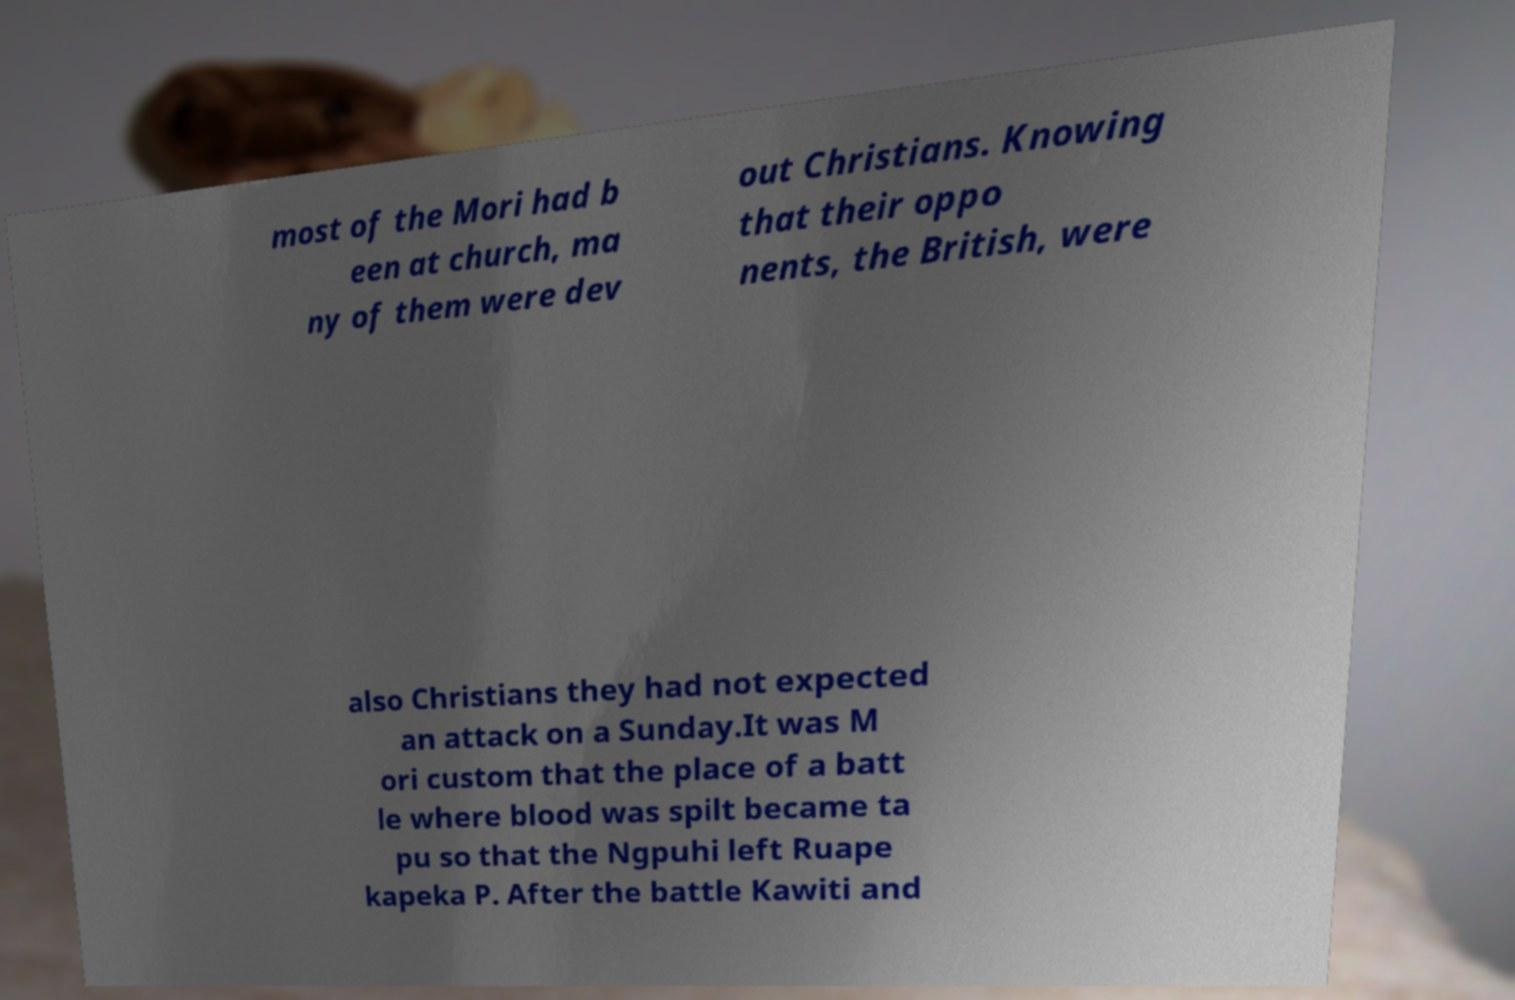What messages or text are displayed in this image? I need them in a readable, typed format. most of the Mori had b een at church, ma ny of them were dev out Christians. Knowing that their oppo nents, the British, were also Christians they had not expected an attack on a Sunday.It was M ori custom that the place of a batt le where blood was spilt became ta pu so that the Ngpuhi left Ruape kapeka P. After the battle Kawiti and 